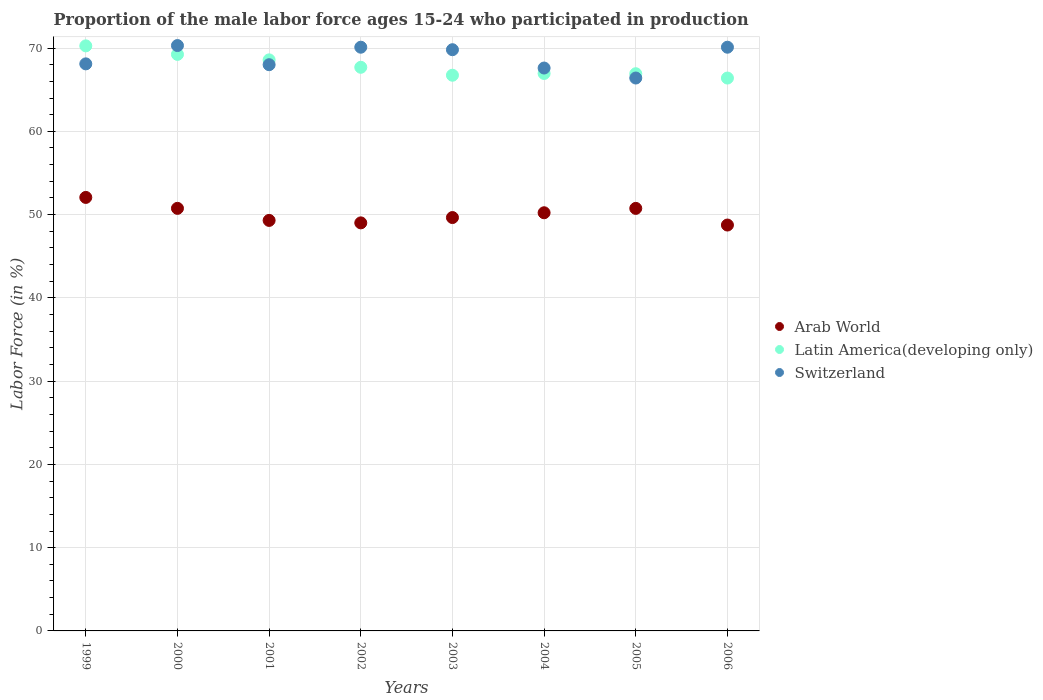Is the number of dotlines equal to the number of legend labels?
Your answer should be very brief. Yes. What is the proportion of the male labor force who participated in production in Arab World in 1999?
Give a very brief answer. 52.06. Across all years, what is the maximum proportion of the male labor force who participated in production in Switzerland?
Your answer should be very brief. 70.3. Across all years, what is the minimum proportion of the male labor force who participated in production in Arab World?
Keep it short and to the point. 48.74. In which year was the proportion of the male labor force who participated in production in Arab World maximum?
Your answer should be very brief. 1999. In which year was the proportion of the male labor force who participated in production in Arab World minimum?
Your answer should be compact. 2006. What is the total proportion of the male labor force who participated in production in Arab World in the graph?
Offer a very short reply. 400.46. What is the difference between the proportion of the male labor force who participated in production in Arab World in 2000 and that in 2006?
Offer a terse response. 2. What is the difference between the proportion of the male labor force who participated in production in Switzerland in 2002 and the proportion of the male labor force who participated in production in Latin America(developing only) in 2003?
Provide a short and direct response. 3.36. What is the average proportion of the male labor force who participated in production in Switzerland per year?
Your answer should be compact. 68.8. In the year 2002, what is the difference between the proportion of the male labor force who participated in production in Latin America(developing only) and proportion of the male labor force who participated in production in Arab World?
Your answer should be compact. 18.68. In how many years, is the proportion of the male labor force who participated in production in Switzerland greater than 8 %?
Your response must be concise. 8. What is the ratio of the proportion of the male labor force who participated in production in Switzerland in 1999 to that in 2005?
Make the answer very short. 1.03. What is the difference between the highest and the second highest proportion of the male labor force who participated in production in Arab World?
Your answer should be very brief. 1.31. What is the difference between the highest and the lowest proportion of the male labor force who participated in production in Arab World?
Your answer should be compact. 3.32. In how many years, is the proportion of the male labor force who participated in production in Arab World greater than the average proportion of the male labor force who participated in production in Arab World taken over all years?
Your response must be concise. 4. Is the sum of the proportion of the male labor force who participated in production in Latin America(developing only) in 2000 and 2001 greater than the maximum proportion of the male labor force who participated in production in Switzerland across all years?
Offer a very short reply. Yes. Is the proportion of the male labor force who participated in production in Arab World strictly less than the proportion of the male labor force who participated in production in Switzerland over the years?
Ensure brevity in your answer.  Yes. What is the difference between two consecutive major ticks on the Y-axis?
Ensure brevity in your answer.  10. Are the values on the major ticks of Y-axis written in scientific E-notation?
Provide a short and direct response. No. Does the graph contain any zero values?
Your response must be concise. No. Does the graph contain grids?
Provide a succinct answer. Yes. How many legend labels are there?
Give a very brief answer. 3. How are the legend labels stacked?
Ensure brevity in your answer.  Vertical. What is the title of the graph?
Your answer should be compact. Proportion of the male labor force ages 15-24 who participated in production. What is the label or title of the X-axis?
Keep it short and to the point. Years. What is the Labor Force (in %) in Arab World in 1999?
Ensure brevity in your answer.  52.06. What is the Labor Force (in %) of Latin America(developing only) in 1999?
Offer a terse response. 70.26. What is the Labor Force (in %) in Switzerland in 1999?
Provide a succinct answer. 68.1. What is the Labor Force (in %) in Arab World in 2000?
Offer a very short reply. 50.75. What is the Labor Force (in %) of Latin America(developing only) in 2000?
Ensure brevity in your answer.  69.24. What is the Labor Force (in %) in Switzerland in 2000?
Offer a terse response. 70.3. What is the Labor Force (in %) of Arab World in 2001?
Your answer should be compact. 49.3. What is the Labor Force (in %) of Latin America(developing only) in 2001?
Your answer should be compact. 68.58. What is the Labor Force (in %) of Arab World in 2002?
Keep it short and to the point. 49. What is the Labor Force (in %) of Latin America(developing only) in 2002?
Your answer should be compact. 67.69. What is the Labor Force (in %) in Switzerland in 2002?
Offer a terse response. 70.1. What is the Labor Force (in %) in Arab World in 2003?
Make the answer very short. 49.64. What is the Labor Force (in %) of Latin America(developing only) in 2003?
Provide a succinct answer. 66.74. What is the Labor Force (in %) in Switzerland in 2003?
Your answer should be compact. 69.8. What is the Labor Force (in %) of Arab World in 2004?
Keep it short and to the point. 50.22. What is the Labor Force (in %) of Latin America(developing only) in 2004?
Your response must be concise. 66.95. What is the Labor Force (in %) of Switzerland in 2004?
Keep it short and to the point. 67.6. What is the Labor Force (in %) in Arab World in 2005?
Offer a very short reply. 50.74. What is the Labor Force (in %) of Latin America(developing only) in 2005?
Your answer should be compact. 66.92. What is the Labor Force (in %) in Switzerland in 2005?
Provide a short and direct response. 66.4. What is the Labor Force (in %) in Arab World in 2006?
Give a very brief answer. 48.74. What is the Labor Force (in %) in Latin America(developing only) in 2006?
Make the answer very short. 66.4. What is the Labor Force (in %) of Switzerland in 2006?
Your answer should be compact. 70.1. Across all years, what is the maximum Labor Force (in %) of Arab World?
Your answer should be compact. 52.06. Across all years, what is the maximum Labor Force (in %) in Latin America(developing only)?
Give a very brief answer. 70.26. Across all years, what is the maximum Labor Force (in %) in Switzerland?
Your answer should be compact. 70.3. Across all years, what is the minimum Labor Force (in %) in Arab World?
Give a very brief answer. 48.74. Across all years, what is the minimum Labor Force (in %) of Latin America(developing only)?
Your answer should be very brief. 66.4. Across all years, what is the minimum Labor Force (in %) of Switzerland?
Your answer should be compact. 66.4. What is the total Labor Force (in %) in Arab World in the graph?
Ensure brevity in your answer.  400.46. What is the total Labor Force (in %) in Latin America(developing only) in the graph?
Make the answer very short. 542.77. What is the total Labor Force (in %) of Switzerland in the graph?
Your response must be concise. 550.4. What is the difference between the Labor Force (in %) in Arab World in 1999 and that in 2000?
Your answer should be very brief. 1.31. What is the difference between the Labor Force (in %) of Latin America(developing only) in 1999 and that in 2000?
Your answer should be compact. 1.02. What is the difference between the Labor Force (in %) in Switzerland in 1999 and that in 2000?
Offer a very short reply. -2.2. What is the difference between the Labor Force (in %) of Arab World in 1999 and that in 2001?
Provide a short and direct response. 2.76. What is the difference between the Labor Force (in %) in Latin America(developing only) in 1999 and that in 2001?
Make the answer very short. 1.68. What is the difference between the Labor Force (in %) in Arab World in 1999 and that in 2002?
Give a very brief answer. 3.06. What is the difference between the Labor Force (in %) in Latin America(developing only) in 1999 and that in 2002?
Offer a very short reply. 2.57. What is the difference between the Labor Force (in %) in Arab World in 1999 and that in 2003?
Provide a succinct answer. 2.42. What is the difference between the Labor Force (in %) of Latin America(developing only) in 1999 and that in 2003?
Your answer should be compact. 3.53. What is the difference between the Labor Force (in %) in Switzerland in 1999 and that in 2003?
Provide a short and direct response. -1.7. What is the difference between the Labor Force (in %) of Arab World in 1999 and that in 2004?
Ensure brevity in your answer.  1.84. What is the difference between the Labor Force (in %) in Latin America(developing only) in 1999 and that in 2004?
Offer a very short reply. 3.32. What is the difference between the Labor Force (in %) in Switzerland in 1999 and that in 2004?
Offer a terse response. 0.5. What is the difference between the Labor Force (in %) of Arab World in 1999 and that in 2005?
Your answer should be compact. 1.32. What is the difference between the Labor Force (in %) in Latin America(developing only) in 1999 and that in 2005?
Give a very brief answer. 3.34. What is the difference between the Labor Force (in %) in Switzerland in 1999 and that in 2005?
Your answer should be very brief. 1.7. What is the difference between the Labor Force (in %) in Arab World in 1999 and that in 2006?
Your answer should be very brief. 3.32. What is the difference between the Labor Force (in %) of Latin America(developing only) in 1999 and that in 2006?
Offer a very short reply. 3.87. What is the difference between the Labor Force (in %) in Arab World in 2000 and that in 2001?
Provide a succinct answer. 1.45. What is the difference between the Labor Force (in %) of Latin America(developing only) in 2000 and that in 2001?
Keep it short and to the point. 0.66. What is the difference between the Labor Force (in %) in Arab World in 2000 and that in 2002?
Give a very brief answer. 1.74. What is the difference between the Labor Force (in %) in Latin America(developing only) in 2000 and that in 2002?
Give a very brief answer. 1.55. What is the difference between the Labor Force (in %) of Arab World in 2000 and that in 2003?
Ensure brevity in your answer.  1.1. What is the difference between the Labor Force (in %) of Latin America(developing only) in 2000 and that in 2003?
Make the answer very short. 2.5. What is the difference between the Labor Force (in %) of Switzerland in 2000 and that in 2003?
Offer a very short reply. 0.5. What is the difference between the Labor Force (in %) in Arab World in 2000 and that in 2004?
Provide a succinct answer. 0.53. What is the difference between the Labor Force (in %) of Latin America(developing only) in 2000 and that in 2004?
Ensure brevity in your answer.  2.29. What is the difference between the Labor Force (in %) of Arab World in 2000 and that in 2005?
Your answer should be compact. 0. What is the difference between the Labor Force (in %) of Latin America(developing only) in 2000 and that in 2005?
Your response must be concise. 2.32. What is the difference between the Labor Force (in %) of Switzerland in 2000 and that in 2005?
Make the answer very short. 3.9. What is the difference between the Labor Force (in %) of Arab World in 2000 and that in 2006?
Provide a succinct answer. 2. What is the difference between the Labor Force (in %) in Latin America(developing only) in 2000 and that in 2006?
Offer a terse response. 2.84. What is the difference between the Labor Force (in %) of Arab World in 2001 and that in 2002?
Your answer should be compact. 0.3. What is the difference between the Labor Force (in %) of Latin America(developing only) in 2001 and that in 2002?
Your answer should be very brief. 0.89. What is the difference between the Labor Force (in %) in Switzerland in 2001 and that in 2002?
Offer a very short reply. -2.1. What is the difference between the Labor Force (in %) in Arab World in 2001 and that in 2003?
Provide a succinct answer. -0.34. What is the difference between the Labor Force (in %) of Latin America(developing only) in 2001 and that in 2003?
Offer a very short reply. 1.84. What is the difference between the Labor Force (in %) of Arab World in 2001 and that in 2004?
Keep it short and to the point. -0.92. What is the difference between the Labor Force (in %) of Latin America(developing only) in 2001 and that in 2004?
Your response must be concise. 1.63. What is the difference between the Labor Force (in %) in Switzerland in 2001 and that in 2004?
Your response must be concise. 0.4. What is the difference between the Labor Force (in %) in Arab World in 2001 and that in 2005?
Give a very brief answer. -1.44. What is the difference between the Labor Force (in %) of Latin America(developing only) in 2001 and that in 2005?
Offer a very short reply. 1.66. What is the difference between the Labor Force (in %) of Arab World in 2001 and that in 2006?
Keep it short and to the point. 0.56. What is the difference between the Labor Force (in %) of Latin America(developing only) in 2001 and that in 2006?
Keep it short and to the point. 2.18. What is the difference between the Labor Force (in %) of Arab World in 2002 and that in 2003?
Offer a very short reply. -0.64. What is the difference between the Labor Force (in %) in Latin America(developing only) in 2002 and that in 2003?
Ensure brevity in your answer.  0.95. What is the difference between the Labor Force (in %) of Switzerland in 2002 and that in 2003?
Make the answer very short. 0.3. What is the difference between the Labor Force (in %) of Arab World in 2002 and that in 2004?
Offer a terse response. -1.21. What is the difference between the Labor Force (in %) of Latin America(developing only) in 2002 and that in 2004?
Provide a succinct answer. 0.74. What is the difference between the Labor Force (in %) of Arab World in 2002 and that in 2005?
Make the answer very short. -1.74. What is the difference between the Labor Force (in %) of Latin America(developing only) in 2002 and that in 2005?
Keep it short and to the point. 0.77. What is the difference between the Labor Force (in %) in Arab World in 2002 and that in 2006?
Offer a terse response. 0.26. What is the difference between the Labor Force (in %) in Latin America(developing only) in 2002 and that in 2006?
Give a very brief answer. 1.29. What is the difference between the Labor Force (in %) of Arab World in 2003 and that in 2004?
Provide a short and direct response. -0.57. What is the difference between the Labor Force (in %) of Latin America(developing only) in 2003 and that in 2004?
Give a very brief answer. -0.21. What is the difference between the Labor Force (in %) of Arab World in 2003 and that in 2005?
Offer a very short reply. -1.1. What is the difference between the Labor Force (in %) of Latin America(developing only) in 2003 and that in 2005?
Offer a very short reply. -0.18. What is the difference between the Labor Force (in %) in Switzerland in 2003 and that in 2005?
Provide a short and direct response. 3.4. What is the difference between the Labor Force (in %) of Arab World in 2003 and that in 2006?
Give a very brief answer. 0.9. What is the difference between the Labor Force (in %) in Latin America(developing only) in 2003 and that in 2006?
Your answer should be very brief. 0.34. What is the difference between the Labor Force (in %) of Arab World in 2004 and that in 2005?
Your answer should be very brief. -0.53. What is the difference between the Labor Force (in %) in Latin America(developing only) in 2004 and that in 2005?
Your response must be concise. 0.03. What is the difference between the Labor Force (in %) in Switzerland in 2004 and that in 2005?
Your answer should be compact. 1.2. What is the difference between the Labor Force (in %) in Arab World in 2004 and that in 2006?
Offer a very short reply. 1.47. What is the difference between the Labor Force (in %) of Latin America(developing only) in 2004 and that in 2006?
Provide a short and direct response. 0.55. What is the difference between the Labor Force (in %) of Arab World in 2005 and that in 2006?
Give a very brief answer. 2. What is the difference between the Labor Force (in %) of Latin America(developing only) in 2005 and that in 2006?
Keep it short and to the point. 0.52. What is the difference between the Labor Force (in %) of Arab World in 1999 and the Labor Force (in %) of Latin America(developing only) in 2000?
Give a very brief answer. -17.18. What is the difference between the Labor Force (in %) in Arab World in 1999 and the Labor Force (in %) in Switzerland in 2000?
Offer a very short reply. -18.24. What is the difference between the Labor Force (in %) of Latin America(developing only) in 1999 and the Labor Force (in %) of Switzerland in 2000?
Keep it short and to the point. -0.04. What is the difference between the Labor Force (in %) in Arab World in 1999 and the Labor Force (in %) in Latin America(developing only) in 2001?
Your answer should be compact. -16.52. What is the difference between the Labor Force (in %) of Arab World in 1999 and the Labor Force (in %) of Switzerland in 2001?
Your answer should be compact. -15.94. What is the difference between the Labor Force (in %) of Latin America(developing only) in 1999 and the Labor Force (in %) of Switzerland in 2001?
Provide a short and direct response. 2.26. What is the difference between the Labor Force (in %) in Arab World in 1999 and the Labor Force (in %) in Latin America(developing only) in 2002?
Your answer should be compact. -15.63. What is the difference between the Labor Force (in %) in Arab World in 1999 and the Labor Force (in %) in Switzerland in 2002?
Keep it short and to the point. -18.04. What is the difference between the Labor Force (in %) in Latin America(developing only) in 1999 and the Labor Force (in %) in Switzerland in 2002?
Provide a succinct answer. 0.16. What is the difference between the Labor Force (in %) in Arab World in 1999 and the Labor Force (in %) in Latin America(developing only) in 2003?
Your answer should be compact. -14.68. What is the difference between the Labor Force (in %) in Arab World in 1999 and the Labor Force (in %) in Switzerland in 2003?
Your response must be concise. -17.74. What is the difference between the Labor Force (in %) of Latin America(developing only) in 1999 and the Labor Force (in %) of Switzerland in 2003?
Your response must be concise. 0.46. What is the difference between the Labor Force (in %) in Arab World in 1999 and the Labor Force (in %) in Latin America(developing only) in 2004?
Give a very brief answer. -14.89. What is the difference between the Labor Force (in %) of Arab World in 1999 and the Labor Force (in %) of Switzerland in 2004?
Provide a short and direct response. -15.54. What is the difference between the Labor Force (in %) of Latin America(developing only) in 1999 and the Labor Force (in %) of Switzerland in 2004?
Make the answer very short. 2.66. What is the difference between the Labor Force (in %) of Arab World in 1999 and the Labor Force (in %) of Latin America(developing only) in 2005?
Your answer should be compact. -14.86. What is the difference between the Labor Force (in %) of Arab World in 1999 and the Labor Force (in %) of Switzerland in 2005?
Provide a succinct answer. -14.34. What is the difference between the Labor Force (in %) of Latin America(developing only) in 1999 and the Labor Force (in %) of Switzerland in 2005?
Ensure brevity in your answer.  3.86. What is the difference between the Labor Force (in %) in Arab World in 1999 and the Labor Force (in %) in Latin America(developing only) in 2006?
Offer a terse response. -14.34. What is the difference between the Labor Force (in %) of Arab World in 1999 and the Labor Force (in %) of Switzerland in 2006?
Your answer should be compact. -18.04. What is the difference between the Labor Force (in %) in Latin America(developing only) in 1999 and the Labor Force (in %) in Switzerland in 2006?
Provide a short and direct response. 0.16. What is the difference between the Labor Force (in %) in Arab World in 2000 and the Labor Force (in %) in Latin America(developing only) in 2001?
Your answer should be very brief. -17.83. What is the difference between the Labor Force (in %) of Arab World in 2000 and the Labor Force (in %) of Switzerland in 2001?
Offer a very short reply. -17.25. What is the difference between the Labor Force (in %) of Latin America(developing only) in 2000 and the Labor Force (in %) of Switzerland in 2001?
Your response must be concise. 1.24. What is the difference between the Labor Force (in %) of Arab World in 2000 and the Labor Force (in %) of Latin America(developing only) in 2002?
Your response must be concise. -16.94. What is the difference between the Labor Force (in %) in Arab World in 2000 and the Labor Force (in %) in Switzerland in 2002?
Offer a terse response. -19.35. What is the difference between the Labor Force (in %) in Latin America(developing only) in 2000 and the Labor Force (in %) in Switzerland in 2002?
Provide a short and direct response. -0.86. What is the difference between the Labor Force (in %) in Arab World in 2000 and the Labor Force (in %) in Latin America(developing only) in 2003?
Give a very brief answer. -15.99. What is the difference between the Labor Force (in %) in Arab World in 2000 and the Labor Force (in %) in Switzerland in 2003?
Give a very brief answer. -19.05. What is the difference between the Labor Force (in %) in Latin America(developing only) in 2000 and the Labor Force (in %) in Switzerland in 2003?
Keep it short and to the point. -0.56. What is the difference between the Labor Force (in %) of Arab World in 2000 and the Labor Force (in %) of Latin America(developing only) in 2004?
Offer a very short reply. -16.2. What is the difference between the Labor Force (in %) in Arab World in 2000 and the Labor Force (in %) in Switzerland in 2004?
Make the answer very short. -16.85. What is the difference between the Labor Force (in %) of Latin America(developing only) in 2000 and the Labor Force (in %) of Switzerland in 2004?
Your response must be concise. 1.64. What is the difference between the Labor Force (in %) of Arab World in 2000 and the Labor Force (in %) of Latin America(developing only) in 2005?
Provide a succinct answer. -16.17. What is the difference between the Labor Force (in %) of Arab World in 2000 and the Labor Force (in %) of Switzerland in 2005?
Your answer should be compact. -15.65. What is the difference between the Labor Force (in %) of Latin America(developing only) in 2000 and the Labor Force (in %) of Switzerland in 2005?
Offer a very short reply. 2.84. What is the difference between the Labor Force (in %) of Arab World in 2000 and the Labor Force (in %) of Latin America(developing only) in 2006?
Your response must be concise. -15.65. What is the difference between the Labor Force (in %) of Arab World in 2000 and the Labor Force (in %) of Switzerland in 2006?
Offer a very short reply. -19.35. What is the difference between the Labor Force (in %) in Latin America(developing only) in 2000 and the Labor Force (in %) in Switzerland in 2006?
Give a very brief answer. -0.86. What is the difference between the Labor Force (in %) of Arab World in 2001 and the Labor Force (in %) of Latin America(developing only) in 2002?
Ensure brevity in your answer.  -18.39. What is the difference between the Labor Force (in %) in Arab World in 2001 and the Labor Force (in %) in Switzerland in 2002?
Make the answer very short. -20.8. What is the difference between the Labor Force (in %) of Latin America(developing only) in 2001 and the Labor Force (in %) of Switzerland in 2002?
Ensure brevity in your answer.  -1.52. What is the difference between the Labor Force (in %) in Arab World in 2001 and the Labor Force (in %) in Latin America(developing only) in 2003?
Make the answer very short. -17.44. What is the difference between the Labor Force (in %) in Arab World in 2001 and the Labor Force (in %) in Switzerland in 2003?
Your response must be concise. -20.5. What is the difference between the Labor Force (in %) in Latin America(developing only) in 2001 and the Labor Force (in %) in Switzerland in 2003?
Your answer should be very brief. -1.22. What is the difference between the Labor Force (in %) of Arab World in 2001 and the Labor Force (in %) of Latin America(developing only) in 2004?
Make the answer very short. -17.65. What is the difference between the Labor Force (in %) of Arab World in 2001 and the Labor Force (in %) of Switzerland in 2004?
Your response must be concise. -18.3. What is the difference between the Labor Force (in %) of Latin America(developing only) in 2001 and the Labor Force (in %) of Switzerland in 2004?
Your response must be concise. 0.98. What is the difference between the Labor Force (in %) of Arab World in 2001 and the Labor Force (in %) of Latin America(developing only) in 2005?
Provide a short and direct response. -17.62. What is the difference between the Labor Force (in %) in Arab World in 2001 and the Labor Force (in %) in Switzerland in 2005?
Keep it short and to the point. -17.1. What is the difference between the Labor Force (in %) of Latin America(developing only) in 2001 and the Labor Force (in %) of Switzerland in 2005?
Provide a succinct answer. 2.18. What is the difference between the Labor Force (in %) in Arab World in 2001 and the Labor Force (in %) in Latin America(developing only) in 2006?
Offer a terse response. -17.1. What is the difference between the Labor Force (in %) in Arab World in 2001 and the Labor Force (in %) in Switzerland in 2006?
Ensure brevity in your answer.  -20.8. What is the difference between the Labor Force (in %) of Latin America(developing only) in 2001 and the Labor Force (in %) of Switzerland in 2006?
Your answer should be compact. -1.52. What is the difference between the Labor Force (in %) in Arab World in 2002 and the Labor Force (in %) in Latin America(developing only) in 2003?
Offer a very short reply. -17.73. What is the difference between the Labor Force (in %) in Arab World in 2002 and the Labor Force (in %) in Switzerland in 2003?
Your answer should be compact. -20.8. What is the difference between the Labor Force (in %) of Latin America(developing only) in 2002 and the Labor Force (in %) of Switzerland in 2003?
Your answer should be very brief. -2.11. What is the difference between the Labor Force (in %) in Arab World in 2002 and the Labor Force (in %) in Latin America(developing only) in 2004?
Offer a terse response. -17.94. What is the difference between the Labor Force (in %) in Arab World in 2002 and the Labor Force (in %) in Switzerland in 2004?
Make the answer very short. -18.6. What is the difference between the Labor Force (in %) in Latin America(developing only) in 2002 and the Labor Force (in %) in Switzerland in 2004?
Your response must be concise. 0.09. What is the difference between the Labor Force (in %) of Arab World in 2002 and the Labor Force (in %) of Latin America(developing only) in 2005?
Keep it short and to the point. -17.91. What is the difference between the Labor Force (in %) of Arab World in 2002 and the Labor Force (in %) of Switzerland in 2005?
Offer a very short reply. -17.4. What is the difference between the Labor Force (in %) in Latin America(developing only) in 2002 and the Labor Force (in %) in Switzerland in 2005?
Give a very brief answer. 1.29. What is the difference between the Labor Force (in %) in Arab World in 2002 and the Labor Force (in %) in Latin America(developing only) in 2006?
Your answer should be very brief. -17.39. What is the difference between the Labor Force (in %) in Arab World in 2002 and the Labor Force (in %) in Switzerland in 2006?
Provide a succinct answer. -21.1. What is the difference between the Labor Force (in %) of Latin America(developing only) in 2002 and the Labor Force (in %) of Switzerland in 2006?
Ensure brevity in your answer.  -2.41. What is the difference between the Labor Force (in %) in Arab World in 2003 and the Labor Force (in %) in Latin America(developing only) in 2004?
Your response must be concise. -17.3. What is the difference between the Labor Force (in %) of Arab World in 2003 and the Labor Force (in %) of Switzerland in 2004?
Offer a terse response. -17.96. What is the difference between the Labor Force (in %) in Latin America(developing only) in 2003 and the Labor Force (in %) in Switzerland in 2004?
Give a very brief answer. -0.86. What is the difference between the Labor Force (in %) in Arab World in 2003 and the Labor Force (in %) in Latin America(developing only) in 2005?
Keep it short and to the point. -17.27. What is the difference between the Labor Force (in %) of Arab World in 2003 and the Labor Force (in %) of Switzerland in 2005?
Keep it short and to the point. -16.76. What is the difference between the Labor Force (in %) in Latin America(developing only) in 2003 and the Labor Force (in %) in Switzerland in 2005?
Your answer should be very brief. 0.34. What is the difference between the Labor Force (in %) of Arab World in 2003 and the Labor Force (in %) of Latin America(developing only) in 2006?
Provide a short and direct response. -16.75. What is the difference between the Labor Force (in %) of Arab World in 2003 and the Labor Force (in %) of Switzerland in 2006?
Your response must be concise. -20.46. What is the difference between the Labor Force (in %) in Latin America(developing only) in 2003 and the Labor Force (in %) in Switzerland in 2006?
Your answer should be very brief. -3.36. What is the difference between the Labor Force (in %) of Arab World in 2004 and the Labor Force (in %) of Latin America(developing only) in 2005?
Make the answer very short. -16.7. What is the difference between the Labor Force (in %) in Arab World in 2004 and the Labor Force (in %) in Switzerland in 2005?
Your answer should be compact. -16.18. What is the difference between the Labor Force (in %) in Latin America(developing only) in 2004 and the Labor Force (in %) in Switzerland in 2005?
Keep it short and to the point. 0.55. What is the difference between the Labor Force (in %) in Arab World in 2004 and the Labor Force (in %) in Latin America(developing only) in 2006?
Keep it short and to the point. -16.18. What is the difference between the Labor Force (in %) of Arab World in 2004 and the Labor Force (in %) of Switzerland in 2006?
Provide a succinct answer. -19.88. What is the difference between the Labor Force (in %) of Latin America(developing only) in 2004 and the Labor Force (in %) of Switzerland in 2006?
Make the answer very short. -3.15. What is the difference between the Labor Force (in %) of Arab World in 2005 and the Labor Force (in %) of Latin America(developing only) in 2006?
Offer a terse response. -15.65. What is the difference between the Labor Force (in %) of Arab World in 2005 and the Labor Force (in %) of Switzerland in 2006?
Provide a short and direct response. -19.36. What is the difference between the Labor Force (in %) of Latin America(developing only) in 2005 and the Labor Force (in %) of Switzerland in 2006?
Provide a short and direct response. -3.18. What is the average Labor Force (in %) in Arab World per year?
Your answer should be very brief. 50.06. What is the average Labor Force (in %) in Latin America(developing only) per year?
Keep it short and to the point. 67.85. What is the average Labor Force (in %) in Switzerland per year?
Ensure brevity in your answer.  68.8. In the year 1999, what is the difference between the Labor Force (in %) in Arab World and Labor Force (in %) in Latin America(developing only)?
Offer a terse response. -18.2. In the year 1999, what is the difference between the Labor Force (in %) in Arab World and Labor Force (in %) in Switzerland?
Keep it short and to the point. -16.04. In the year 1999, what is the difference between the Labor Force (in %) of Latin America(developing only) and Labor Force (in %) of Switzerland?
Offer a terse response. 2.16. In the year 2000, what is the difference between the Labor Force (in %) of Arab World and Labor Force (in %) of Latin America(developing only)?
Your answer should be compact. -18.49. In the year 2000, what is the difference between the Labor Force (in %) in Arab World and Labor Force (in %) in Switzerland?
Offer a terse response. -19.55. In the year 2000, what is the difference between the Labor Force (in %) in Latin America(developing only) and Labor Force (in %) in Switzerland?
Provide a succinct answer. -1.06. In the year 2001, what is the difference between the Labor Force (in %) in Arab World and Labor Force (in %) in Latin America(developing only)?
Keep it short and to the point. -19.28. In the year 2001, what is the difference between the Labor Force (in %) of Arab World and Labor Force (in %) of Switzerland?
Your answer should be very brief. -18.7. In the year 2001, what is the difference between the Labor Force (in %) in Latin America(developing only) and Labor Force (in %) in Switzerland?
Your response must be concise. 0.58. In the year 2002, what is the difference between the Labor Force (in %) of Arab World and Labor Force (in %) of Latin America(developing only)?
Offer a terse response. -18.68. In the year 2002, what is the difference between the Labor Force (in %) in Arab World and Labor Force (in %) in Switzerland?
Ensure brevity in your answer.  -21.1. In the year 2002, what is the difference between the Labor Force (in %) of Latin America(developing only) and Labor Force (in %) of Switzerland?
Your answer should be compact. -2.41. In the year 2003, what is the difference between the Labor Force (in %) in Arab World and Labor Force (in %) in Latin America(developing only)?
Make the answer very short. -17.09. In the year 2003, what is the difference between the Labor Force (in %) of Arab World and Labor Force (in %) of Switzerland?
Provide a succinct answer. -20.16. In the year 2003, what is the difference between the Labor Force (in %) in Latin America(developing only) and Labor Force (in %) in Switzerland?
Offer a very short reply. -3.06. In the year 2004, what is the difference between the Labor Force (in %) in Arab World and Labor Force (in %) in Latin America(developing only)?
Ensure brevity in your answer.  -16.73. In the year 2004, what is the difference between the Labor Force (in %) in Arab World and Labor Force (in %) in Switzerland?
Offer a terse response. -17.38. In the year 2004, what is the difference between the Labor Force (in %) of Latin America(developing only) and Labor Force (in %) of Switzerland?
Provide a short and direct response. -0.65. In the year 2005, what is the difference between the Labor Force (in %) in Arab World and Labor Force (in %) in Latin America(developing only)?
Keep it short and to the point. -16.17. In the year 2005, what is the difference between the Labor Force (in %) of Arab World and Labor Force (in %) of Switzerland?
Ensure brevity in your answer.  -15.66. In the year 2005, what is the difference between the Labor Force (in %) in Latin America(developing only) and Labor Force (in %) in Switzerland?
Ensure brevity in your answer.  0.52. In the year 2006, what is the difference between the Labor Force (in %) of Arab World and Labor Force (in %) of Latin America(developing only)?
Offer a very short reply. -17.65. In the year 2006, what is the difference between the Labor Force (in %) of Arab World and Labor Force (in %) of Switzerland?
Provide a short and direct response. -21.36. In the year 2006, what is the difference between the Labor Force (in %) in Latin America(developing only) and Labor Force (in %) in Switzerland?
Provide a succinct answer. -3.7. What is the ratio of the Labor Force (in %) of Arab World in 1999 to that in 2000?
Your answer should be compact. 1.03. What is the ratio of the Labor Force (in %) of Latin America(developing only) in 1999 to that in 2000?
Your response must be concise. 1.01. What is the ratio of the Labor Force (in %) in Switzerland in 1999 to that in 2000?
Offer a very short reply. 0.97. What is the ratio of the Labor Force (in %) in Arab World in 1999 to that in 2001?
Your answer should be very brief. 1.06. What is the ratio of the Labor Force (in %) of Latin America(developing only) in 1999 to that in 2001?
Provide a succinct answer. 1.02. What is the ratio of the Labor Force (in %) in Arab World in 1999 to that in 2002?
Keep it short and to the point. 1.06. What is the ratio of the Labor Force (in %) of Latin America(developing only) in 1999 to that in 2002?
Ensure brevity in your answer.  1.04. What is the ratio of the Labor Force (in %) in Switzerland in 1999 to that in 2002?
Provide a short and direct response. 0.97. What is the ratio of the Labor Force (in %) in Arab World in 1999 to that in 2003?
Give a very brief answer. 1.05. What is the ratio of the Labor Force (in %) in Latin America(developing only) in 1999 to that in 2003?
Make the answer very short. 1.05. What is the ratio of the Labor Force (in %) of Switzerland in 1999 to that in 2003?
Your answer should be compact. 0.98. What is the ratio of the Labor Force (in %) of Arab World in 1999 to that in 2004?
Your answer should be very brief. 1.04. What is the ratio of the Labor Force (in %) in Latin America(developing only) in 1999 to that in 2004?
Your response must be concise. 1.05. What is the ratio of the Labor Force (in %) of Switzerland in 1999 to that in 2004?
Offer a terse response. 1.01. What is the ratio of the Labor Force (in %) in Switzerland in 1999 to that in 2005?
Offer a very short reply. 1.03. What is the ratio of the Labor Force (in %) in Arab World in 1999 to that in 2006?
Give a very brief answer. 1.07. What is the ratio of the Labor Force (in %) of Latin America(developing only) in 1999 to that in 2006?
Offer a terse response. 1.06. What is the ratio of the Labor Force (in %) in Switzerland in 1999 to that in 2006?
Your answer should be compact. 0.97. What is the ratio of the Labor Force (in %) in Arab World in 2000 to that in 2001?
Your answer should be very brief. 1.03. What is the ratio of the Labor Force (in %) of Latin America(developing only) in 2000 to that in 2001?
Offer a very short reply. 1.01. What is the ratio of the Labor Force (in %) in Switzerland in 2000 to that in 2001?
Keep it short and to the point. 1.03. What is the ratio of the Labor Force (in %) in Arab World in 2000 to that in 2002?
Keep it short and to the point. 1.04. What is the ratio of the Labor Force (in %) in Latin America(developing only) in 2000 to that in 2002?
Provide a short and direct response. 1.02. What is the ratio of the Labor Force (in %) in Arab World in 2000 to that in 2003?
Ensure brevity in your answer.  1.02. What is the ratio of the Labor Force (in %) of Latin America(developing only) in 2000 to that in 2003?
Provide a succinct answer. 1.04. What is the ratio of the Labor Force (in %) of Arab World in 2000 to that in 2004?
Your answer should be compact. 1.01. What is the ratio of the Labor Force (in %) of Latin America(developing only) in 2000 to that in 2004?
Provide a short and direct response. 1.03. What is the ratio of the Labor Force (in %) of Switzerland in 2000 to that in 2004?
Give a very brief answer. 1.04. What is the ratio of the Labor Force (in %) in Arab World in 2000 to that in 2005?
Provide a succinct answer. 1. What is the ratio of the Labor Force (in %) in Latin America(developing only) in 2000 to that in 2005?
Ensure brevity in your answer.  1.03. What is the ratio of the Labor Force (in %) in Switzerland in 2000 to that in 2005?
Make the answer very short. 1.06. What is the ratio of the Labor Force (in %) in Arab World in 2000 to that in 2006?
Offer a terse response. 1.04. What is the ratio of the Labor Force (in %) of Latin America(developing only) in 2000 to that in 2006?
Offer a very short reply. 1.04. What is the ratio of the Labor Force (in %) of Switzerland in 2000 to that in 2006?
Ensure brevity in your answer.  1. What is the ratio of the Labor Force (in %) in Arab World in 2001 to that in 2002?
Keep it short and to the point. 1.01. What is the ratio of the Labor Force (in %) in Latin America(developing only) in 2001 to that in 2002?
Your response must be concise. 1.01. What is the ratio of the Labor Force (in %) of Latin America(developing only) in 2001 to that in 2003?
Provide a succinct answer. 1.03. What is the ratio of the Labor Force (in %) in Switzerland in 2001 to that in 2003?
Make the answer very short. 0.97. What is the ratio of the Labor Force (in %) in Arab World in 2001 to that in 2004?
Keep it short and to the point. 0.98. What is the ratio of the Labor Force (in %) in Latin America(developing only) in 2001 to that in 2004?
Your answer should be very brief. 1.02. What is the ratio of the Labor Force (in %) of Switzerland in 2001 to that in 2004?
Your answer should be compact. 1.01. What is the ratio of the Labor Force (in %) in Arab World in 2001 to that in 2005?
Your response must be concise. 0.97. What is the ratio of the Labor Force (in %) in Latin America(developing only) in 2001 to that in 2005?
Your answer should be very brief. 1.02. What is the ratio of the Labor Force (in %) of Switzerland in 2001 to that in 2005?
Your answer should be very brief. 1.02. What is the ratio of the Labor Force (in %) in Arab World in 2001 to that in 2006?
Keep it short and to the point. 1.01. What is the ratio of the Labor Force (in %) in Latin America(developing only) in 2001 to that in 2006?
Your answer should be compact. 1.03. What is the ratio of the Labor Force (in %) of Switzerland in 2001 to that in 2006?
Keep it short and to the point. 0.97. What is the ratio of the Labor Force (in %) of Arab World in 2002 to that in 2003?
Keep it short and to the point. 0.99. What is the ratio of the Labor Force (in %) in Latin America(developing only) in 2002 to that in 2003?
Ensure brevity in your answer.  1.01. What is the ratio of the Labor Force (in %) of Switzerland in 2002 to that in 2003?
Give a very brief answer. 1. What is the ratio of the Labor Force (in %) of Arab World in 2002 to that in 2004?
Give a very brief answer. 0.98. What is the ratio of the Labor Force (in %) of Latin America(developing only) in 2002 to that in 2004?
Your answer should be very brief. 1.01. What is the ratio of the Labor Force (in %) in Arab World in 2002 to that in 2005?
Keep it short and to the point. 0.97. What is the ratio of the Labor Force (in %) of Latin America(developing only) in 2002 to that in 2005?
Provide a succinct answer. 1.01. What is the ratio of the Labor Force (in %) in Switzerland in 2002 to that in 2005?
Provide a short and direct response. 1.06. What is the ratio of the Labor Force (in %) in Latin America(developing only) in 2002 to that in 2006?
Provide a succinct answer. 1.02. What is the ratio of the Labor Force (in %) in Arab World in 2003 to that in 2004?
Offer a very short reply. 0.99. What is the ratio of the Labor Force (in %) in Latin America(developing only) in 2003 to that in 2004?
Provide a succinct answer. 1. What is the ratio of the Labor Force (in %) of Switzerland in 2003 to that in 2004?
Your answer should be very brief. 1.03. What is the ratio of the Labor Force (in %) in Arab World in 2003 to that in 2005?
Offer a terse response. 0.98. What is the ratio of the Labor Force (in %) in Latin America(developing only) in 2003 to that in 2005?
Ensure brevity in your answer.  1. What is the ratio of the Labor Force (in %) of Switzerland in 2003 to that in 2005?
Your answer should be compact. 1.05. What is the ratio of the Labor Force (in %) in Arab World in 2003 to that in 2006?
Give a very brief answer. 1.02. What is the ratio of the Labor Force (in %) in Latin America(developing only) in 2003 to that in 2006?
Make the answer very short. 1.01. What is the ratio of the Labor Force (in %) in Arab World in 2004 to that in 2005?
Provide a succinct answer. 0.99. What is the ratio of the Labor Force (in %) of Switzerland in 2004 to that in 2005?
Provide a short and direct response. 1.02. What is the ratio of the Labor Force (in %) in Arab World in 2004 to that in 2006?
Offer a very short reply. 1.03. What is the ratio of the Labor Force (in %) of Latin America(developing only) in 2004 to that in 2006?
Provide a succinct answer. 1.01. What is the ratio of the Labor Force (in %) in Switzerland in 2004 to that in 2006?
Keep it short and to the point. 0.96. What is the ratio of the Labor Force (in %) in Arab World in 2005 to that in 2006?
Offer a terse response. 1.04. What is the ratio of the Labor Force (in %) of Latin America(developing only) in 2005 to that in 2006?
Keep it short and to the point. 1.01. What is the ratio of the Labor Force (in %) of Switzerland in 2005 to that in 2006?
Your response must be concise. 0.95. What is the difference between the highest and the second highest Labor Force (in %) in Arab World?
Provide a short and direct response. 1.31. What is the difference between the highest and the second highest Labor Force (in %) in Latin America(developing only)?
Your answer should be very brief. 1.02. What is the difference between the highest and the second highest Labor Force (in %) of Switzerland?
Ensure brevity in your answer.  0.2. What is the difference between the highest and the lowest Labor Force (in %) of Arab World?
Your answer should be very brief. 3.32. What is the difference between the highest and the lowest Labor Force (in %) in Latin America(developing only)?
Offer a very short reply. 3.87. 